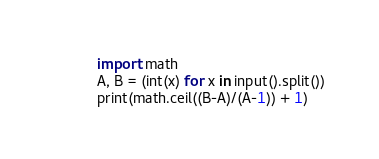<code> <loc_0><loc_0><loc_500><loc_500><_Python_>import math
A, B = (int(x) for x in input().split())
print(math.ceil((B-A)/(A-1)) + 1)</code> 